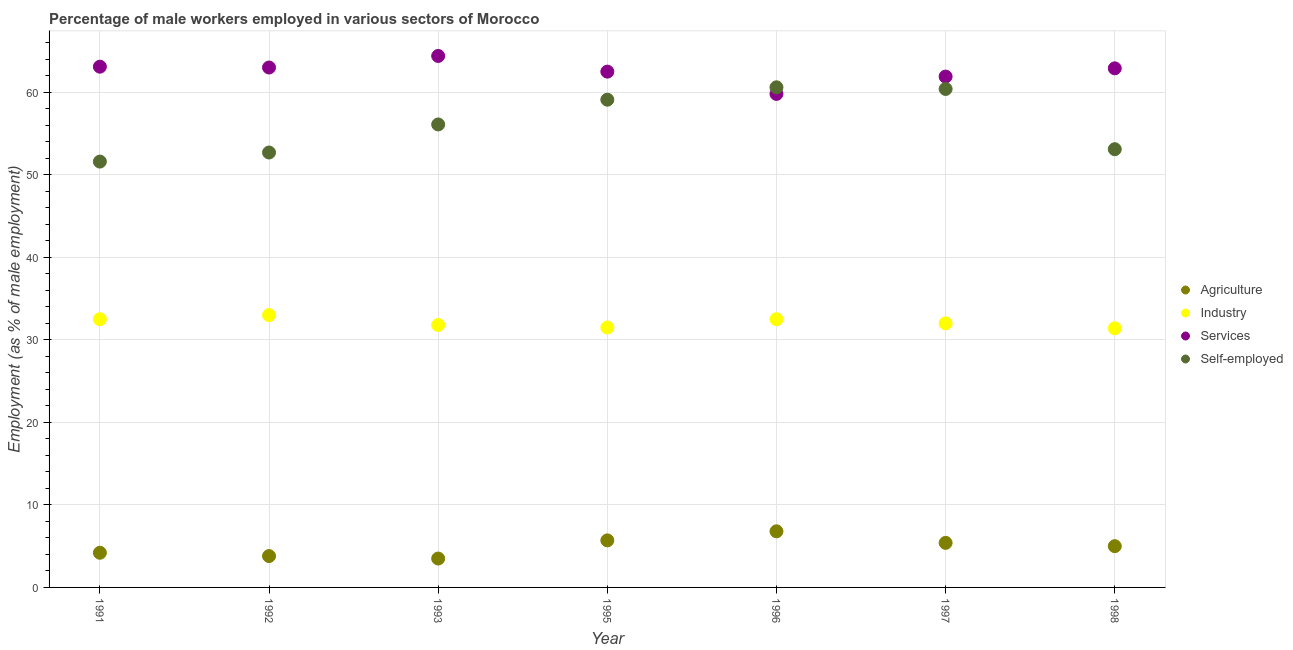How many different coloured dotlines are there?
Offer a very short reply. 4. Is the number of dotlines equal to the number of legend labels?
Your answer should be compact. Yes. What is the percentage of male workers in industry in 1993?
Offer a very short reply. 31.8. Across all years, what is the minimum percentage of male workers in services?
Give a very brief answer. 59.8. In which year was the percentage of male workers in services maximum?
Make the answer very short. 1993. In which year was the percentage of self employed male workers minimum?
Provide a short and direct response. 1991. What is the total percentage of male workers in services in the graph?
Make the answer very short. 437.6. What is the difference between the percentage of male workers in agriculture in 1992 and that in 1993?
Offer a very short reply. 0.3. What is the difference between the percentage of male workers in services in 1997 and the percentage of male workers in agriculture in 1992?
Make the answer very short. 58.1. What is the average percentage of male workers in agriculture per year?
Your answer should be very brief. 4.91. In the year 1993, what is the difference between the percentage of self employed male workers and percentage of male workers in services?
Provide a succinct answer. -8.3. In how many years, is the percentage of male workers in agriculture greater than 54 %?
Provide a succinct answer. 0. What is the ratio of the percentage of male workers in agriculture in 1992 to that in 1996?
Offer a terse response. 0.56. Is the percentage of male workers in industry in 1992 less than that in 1995?
Provide a succinct answer. No. What is the difference between the highest and the second highest percentage of male workers in services?
Provide a short and direct response. 1.3. What is the difference between the highest and the lowest percentage of male workers in services?
Make the answer very short. 4.6. Is it the case that in every year, the sum of the percentage of male workers in agriculture and percentage of male workers in industry is greater than the percentage of male workers in services?
Give a very brief answer. No. Does the percentage of male workers in industry monotonically increase over the years?
Provide a short and direct response. No. Are the values on the major ticks of Y-axis written in scientific E-notation?
Provide a short and direct response. No. Does the graph contain any zero values?
Your response must be concise. No. Does the graph contain grids?
Your answer should be compact. Yes. Where does the legend appear in the graph?
Offer a very short reply. Center right. How many legend labels are there?
Provide a succinct answer. 4. How are the legend labels stacked?
Your answer should be very brief. Vertical. What is the title of the graph?
Provide a short and direct response. Percentage of male workers employed in various sectors of Morocco. What is the label or title of the Y-axis?
Keep it short and to the point. Employment (as % of male employment). What is the Employment (as % of male employment) of Agriculture in 1991?
Make the answer very short. 4.2. What is the Employment (as % of male employment) of Industry in 1991?
Offer a terse response. 32.5. What is the Employment (as % of male employment) of Services in 1991?
Provide a short and direct response. 63.1. What is the Employment (as % of male employment) of Self-employed in 1991?
Offer a very short reply. 51.6. What is the Employment (as % of male employment) of Agriculture in 1992?
Keep it short and to the point. 3.8. What is the Employment (as % of male employment) of Industry in 1992?
Provide a short and direct response. 33. What is the Employment (as % of male employment) in Services in 1992?
Your answer should be compact. 63. What is the Employment (as % of male employment) in Self-employed in 1992?
Your answer should be compact. 52.7. What is the Employment (as % of male employment) of Industry in 1993?
Ensure brevity in your answer.  31.8. What is the Employment (as % of male employment) in Services in 1993?
Provide a short and direct response. 64.4. What is the Employment (as % of male employment) in Self-employed in 1993?
Provide a succinct answer. 56.1. What is the Employment (as % of male employment) in Agriculture in 1995?
Offer a terse response. 5.7. What is the Employment (as % of male employment) in Industry in 1995?
Your answer should be compact. 31.5. What is the Employment (as % of male employment) of Services in 1995?
Keep it short and to the point. 62.5. What is the Employment (as % of male employment) in Self-employed in 1995?
Your response must be concise. 59.1. What is the Employment (as % of male employment) in Agriculture in 1996?
Ensure brevity in your answer.  6.8. What is the Employment (as % of male employment) of Industry in 1996?
Your response must be concise. 32.5. What is the Employment (as % of male employment) of Services in 1996?
Keep it short and to the point. 59.8. What is the Employment (as % of male employment) in Self-employed in 1996?
Your answer should be compact. 60.6. What is the Employment (as % of male employment) in Agriculture in 1997?
Make the answer very short. 5.4. What is the Employment (as % of male employment) of Services in 1997?
Provide a succinct answer. 61.9. What is the Employment (as % of male employment) of Self-employed in 1997?
Provide a short and direct response. 60.4. What is the Employment (as % of male employment) in Agriculture in 1998?
Give a very brief answer. 5. What is the Employment (as % of male employment) of Industry in 1998?
Provide a succinct answer. 31.4. What is the Employment (as % of male employment) in Services in 1998?
Your answer should be very brief. 62.9. What is the Employment (as % of male employment) of Self-employed in 1998?
Provide a short and direct response. 53.1. Across all years, what is the maximum Employment (as % of male employment) in Agriculture?
Give a very brief answer. 6.8. Across all years, what is the maximum Employment (as % of male employment) of Services?
Offer a terse response. 64.4. Across all years, what is the maximum Employment (as % of male employment) of Self-employed?
Offer a very short reply. 60.6. Across all years, what is the minimum Employment (as % of male employment) of Industry?
Provide a short and direct response. 31.4. Across all years, what is the minimum Employment (as % of male employment) in Services?
Offer a terse response. 59.8. Across all years, what is the minimum Employment (as % of male employment) in Self-employed?
Ensure brevity in your answer.  51.6. What is the total Employment (as % of male employment) in Agriculture in the graph?
Keep it short and to the point. 34.4. What is the total Employment (as % of male employment) in Industry in the graph?
Give a very brief answer. 224.7. What is the total Employment (as % of male employment) of Services in the graph?
Provide a succinct answer. 437.6. What is the total Employment (as % of male employment) in Self-employed in the graph?
Your response must be concise. 393.6. What is the difference between the Employment (as % of male employment) in Industry in 1991 and that in 1992?
Your response must be concise. -0.5. What is the difference between the Employment (as % of male employment) in Services in 1991 and that in 1992?
Give a very brief answer. 0.1. What is the difference between the Employment (as % of male employment) of Agriculture in 1991 and that in 1993?
Your response must be concise. 0.7. What is the difference between the Employment (as % of male employment) of Industry in 1991 and that in 1993?
Provide a succinct answer. 0.7. What is the difference between the Employment (as % of male employment) of Self-employed in 1991 and that in 1993?
Your answer should be compact. -4.5. What is the difference between the Employment (as % of male employment) of Agriculture in 1991 and that in 1995?
Provide a short and direct response. -1.5. What is the difference between the Employment (as % of male employment) of Industry in 1991 and that in 1995?
Your answer should be compact. 1. What is the difference between the Employment (as % of male employment) of Services in 1991 and that in 1995?
Offer a terse response. 0.6. What is the difference between the Employment (as % of male employment) of Self-employed in 1991 and that in 1995?
Give a very brief answer. -7.5. What is the difference between the Employment (as % of male employment) of Services in 1991 and that in 1996?
Your answer should be very brief. 3.3. What is the difference between the Employment (as % of male employment) in Self-employed in 1991 and that in 1996?
Your answer should be compact. -9. What is the difference between the Employment (as % of male employment) of Agriculture in 1991 and that in 1997?
Provide a short and direct response. -1.2. What is the difference between the Employment (as % of male employment) of Services in 1991 and that in 1997?
Keep it short and to the point. 1.2. What is the difference between the Employment (as % of male employment) in Industry in 1991 and that in 1998?
Offer a very short reply. 1.1. What is the difference between the Employment (as % of male employment) in Services in 1991 and that in 1998?
Ensure brevity in your answer.  0.2. What is the difference between the Employment (as % of male employment) in Agriculture in 1992 and that in 1993?
Your response must be concise. 0.3. What is the difference between the Employment (as % of male employment) in Industry in 1992 and that in 1993?
Keep it short and to the point. 1.2. What is the difference between the Employment (as % of male employment) in Self-employed in 1992 and that in 1993?
Provide a short and direct response. -3.4. What is the difference between the Employment (as % of male employment) of Industry in 1992 and that in 1995?
Give a very brief answer. 1.5. What is the difference between the Employment (as % of male employment) in Agriculture in 1992 and that in 1996?
Make the answer very short. -3. What is the difference between the Employment (as % of male employment) in Industry in 1992 and that in 1996?
Offer a very short reply. 0.5. What is the difference between the Employment (as % of male employment) of Services in 1992 and that in 1996?
Keep it short and to the point. 3.2. What is the difference between the Employment (as % of male employment) of Self-employed in 1992 and that in 1996?
Offer a terse response. -7.9. What is the difference between the Employment (as % of male employment) in Industry in 1992 and that in 1997?
Offer a terse response. 1. What is the difference between the Employment (as % of male employment) of Self-employed in 1992 and that in 1997?
Give a very brief answer. -7.7. What is the difference between the Employment (as % of male employment) of Agriculture in 1992 and that in 1998?
Provide a short and direct response. -1.2. What is the difference between the Employment (as % of male employment) in Industry in 1992 and that in 1998?
Your response must be concise. 1.6. What is the difference between the Employment (as % of male employment) of Services in 1992 and that in 1998?
Your response must be concise. 0.1. What is the difference between the Employment (as % of male employment) of Services in 1993 and that in 1995?
Ensure brevity in your answer.  1.9. What is the difference between the Employment (as % of male employment) in Self-employed in 1993 and that in 1995?
Offer a terse response. -3. What is the difference between the Employment (as % of male employment) in Agriculture in 1993 and that in 1996?
Provide a short and direct response. -3.3. What is the difference between the Employment (as % of male employment) in Industry in 1993 and that in 1996?
Provide a succinct answer. -0.7. What is the difference between the Employment (as % of male employment) of Agriculture in 1993 and that in 1997?
Offer a very short reply. -1.9. What is the difference between the Employment (as % of male employment) in Industry in 1993 and that in 1997?
Your answer should be very brief. -0.2. What is the difference between the Employment (as % of male employment) in Self-employed in 1993 and that in 1997?
Your response must be concise. -4.3. What is the difference between the Employment (as % of male employment) of Agriculture in 1993 and that in 1998?
Keep it short and to the point. -1.5. What is the difference between the Employment (as % of male employment) of Industry in 1993 and that in 1998?
Make the answer very short. 0.4. What is the difference between the Employment (as % of male employment) in Services in 1993 and that in 1998?
Give a very brief answer. 1.5. What is the difference between the Employment (as % of male employment) in Agriculture in 1995 and that in 1996?
Offer a terse response. -1.1. What is the difference between the Employment (as % of male employment) in Industry in 1995 and that in 1996?
Make the answer very short. -1. What is the difference between the Employment (as % of male employment) in Agriculture in 1995 and that in 1998?
Your response must be concise. 0.7. What is the difference between the Employment (as % of male employment) in Agriculture in 1996 and that in 1997?
Provide a short and direct response. 1.4. What is the difference between the Employment (as % of male employment) of Industry in 1996 and that in 1997?
Offer a very short reply. 0.5. What is the difference between the Employment (as % of male employment) in Services in 1996 and that in 1997?
Offer a very short reply. -2.1. What is the difference between the Employment (as % of male employment) of Agriculture in 1997 and that in 1998?
Offer a very short reply. 0.4. What is the difference between the Employment (as % of male employment) of Agriculture in 1991 and the Employment (as % of male employment) of Industry in 1992?
Provide a succinct answer. -28.8. What is the difference between the Employment (as % of male employment) of Agriculture in 1991 and the Employment (as % of male employment) of Services in 1992?
Keep it short and to the point. -58.8. What is the difference between the Employment (as % of male employment) in Agriculture in 1991 and the Employment (as % of male employment) in Self-employed in 1992?
Keep it short and to the point. -48.5. What is the difference between the Employment (as % of male employment) in Industry in 1991 and the Employment (as % of male employment) in Services in 1992?
Keep it short and to the point. -30.5. What is the difference between the Employment (as % of male employment) in Industry in 1991 and the Employment (as % of male employment) in Self-employed in 1992?
Ensure brevity in your answer.  -20.2. What is the difference between the Employment (as % of male employment) in Services in 1991 and the Employment (as % of male employment) in Self-employed in 1992?
Offer a terse response. 10.4. What is the difference between the Employment (as % of male employment) of Agriculture in 1991 and the Employment (as % of male employment) of Industry in 1993?
Give a very brief answer. -27.6. What is the difference between the Employment (as % of male employment) of Agriculture in 1991 and the Employment (as % of male employment) of Services in 1993?
Your answer should be very brief. -60.2. What is the difference between the Employment (as % of male employment) of Agriculture in 1991 and the Employment (as % of male employment) of Self-employed in 1993?
Give a very brief answer. -51.9. What is the difference between the Employment (as % of male employment) in Industry in 1991 and the Employment (as % of male employment) in Services in 1993?
Offer a very short reply. -31.9. What is the difference between the Employment (as % of male employment) of Industry in 1991 and the Employment (as % of male employment) of Self-employed in 1993?
Your response must be concise. -23.6. What is the difference between the Employment (as % of male employment) in Agriculture in 1991 and the Employment (as % of male employment) in Industry in 1995?
Your answer should be very brief. -27.3. What is the difference between the Employment (as % of male employment) of Agriculture in 1991 and the Employment (as % of male employment) of Services in 1995?
Ensure brevity in your answer.  -58.3. What is the difference between the Employment (as % of male employment) of Agriculture in 1991 and the Employment (as % of male employment) of Self-employed in 1995?
Provide a short and direct response. -54.9. What is the difference between the Employment (as % of male employment) of Industry in 1991 and the Employment (as % of male employment) of Services in 1995?
Your answer should be very brief. -30. What is the difference between the Employment (as % of male employment) in Industry in 1991 and the Employment (as % of male employment) in Self-employed in 1995?
Make the answer very short. -26.6. What is the difference between the Employment (as % of male employment) of Services in 1991 and the Employment (as % of male employment) of Self-employed in 1995?
Your response must be concise. 4. What is the difference between the Employment (as % of male employment) in Agriculture in 1991 and the Employment (as % of male employment) in Industry in 1996?
Make the answer very short. -28.3. What is the difference between the Employment (as % of male employment) in Agriculture in 1991 and the Employment (as % of male employment) in Services in 1996?
Offer a very short reply. -55.6. What is the difference between the Employment (as % of male employment) in Agriculture in 1991 and the Employment (as % of male employment) in Self-employed in 1996?
Your response must be concise. -56.4. What is the difference between the Employment (as % of male employment) of Industry in 1991 and the Employment (as % of male employment) of Services in 1996?
Your answer should be very brief. -27.3. What is the difference between the Employment (as % of male employment) in Industry in 1991 and the Employment (as % of male employment) in Self-employed in 1996?
Provide a short and direct response. -28.1. What is the difference between the Employment (as % of male employment) in Agriculture in 1991 and the Employment (as % of male employment) in Industry in 1997?
Provide a short and direct response. -27.8. What is the difference between the Employment (as % of male employment) of Agriculture in 1991 and the Employment (as % of male employment) of Services in 1997?
Your answer should be very brief. -57.7. What is the difference between the Employment (as % of male employment) in Agriculture in 1991 and the Employment (as % of male employment) in Self-employed in 1997?
Keep it short and to the point. -56.2. What is the difference between the Employment (as % of male employment) in Industry in 1991 and the Employment (as % of male employment) in Services in 1997?
Offer a terse response. -29.4. What is the difference between the Employment (as % of male employment) of Industry in 1991 and the Employment (as % of male employment) of Self-employed in 1997?
Your answer should be compact. -27.9. What is the difference between the Employment (as % of male employment) of Agriculture in 1991 and the Employment (as % of male employment) of Industry in 1998?
Offer a very short reply. -27.2. What is the difference between the Employment (as % of male employment) of Agriculture in 1991 and the Employment (as % of male employment) of Services in 1998?
Give a very brief answer. -58.7. What is the difference between the Employment (as % of male employment) of Agriculture in 1991 and the Employment (as % of male employment) of Self-employed in 1998?
Your answer should be compact. -48.9. What is the difference between the Employment (as % of male employment) of Industry in 1991 and the Employment (as % of male employment) of Services in 1998?
Your answer should be very brief. -30.4. What is the difference between the Employment (as % of male employment) in Industry in 1991 and the Employment (as % of male employment) in Self-employed in 1998?
Make the answer very short. -20.6. What is the difference between the Employment (as % of male employment) in Agriculture in 1992 and the Employment (as % of male employment) in Services in 1993?
Provide a short and direct response. -60.6. What is the difference between the Employment (as % of male employment) of Agriculture in 1992 and the Employment (as % of male employment) of Self-employed in 1993?
Provide a succinct answer. -52.3. What is the difference between the Employment (as % of male employment) in Industry in 1992 and the Employment (as % of male employment) in Services in 1993?
Your response must be concise. -31.4. What is the difference between the Employment (as % of male employment) of Industry in 1992 and the Employment (as % of male employment) of Self-employed in 1993?
Provide a succinct answer. -23.1. What is the difference between the Employment (as % of male employment) in Agriculture in 1992 and the Employment (as % of male employment) in Industry in 1995?
Offer a terse response. -27.7. What is the difference between the Employment (as % of male employment) of Agriculture in 1992 and the Employment (as % of male employment) of Services in 1995?
Keep it short and to the point. -58.7. What is the difference between the Employment (as % of male employment) of Agriculture in 1992 and the Employment (as % of male employment) of Self-employed in 1995?
Your response must be concise. -55.3. What is the difference between the Employment (as % of male employment) of Industry in 1992 and the Employment (as % of male employment) of Services in 1995?
Give a very brief answer. -29.5. What is the difference between the Employment (as % of male employment) of Industry in 1992 and the Employment (as % of male employment) of Self-employed in 1995?
Provide a succinct answer. -26.1. What is the difference between the Employment (as % of male employment) of Services in 1992 and the Employment (as % of male employment) of Self-employed in 1995?
Your answer should be compact. 3.9. What is the difference between the Employment (as % of male employment) of Agriculture in 1992 and the Employment (as % of male employment) of Industry in 1996?
Offer a terse response. -28.7. What is the difference between the Employment (as % of male employment) of Agriculture in 1992 and the Employment (as % of male employment) of Services in 1996?
Your answer should be compact. -56. What is the difference between the Employment (as % of male employment) of Agriculture in 1992 and the Employment (as % of male employment) of Self-employed in 1996?
Your answer should be very brief. -56.8. What is the difference between the Employment (as % of male employment) of Industry in 1992 and the Employment (as % of male employment) of Services in 1996?
Provide a short and direct response. -26.8. What is the difference between the Employment (as % of male employment) in Industry in 1992 and the Employment (as % of male employment) in Self-employed in 1996?
Provide a short and direct response. -27.6. What is the difference between the Employment (as % of male employment) in Services in 1992 and the Employment (as % of male employment) in Self-employed in 1996?
Give a very brief answer. 2.4. What is the difference between the Employment (as % of male employment) of Agriculture in 1992 and the Employment (as % of male employment) of Industry in 1997?
Provide a short and direct response. -28.2. What is the difference between the Employment (as % of male employment) of Agriculture in 1992 and the Employment (as % of male employment) of Services in 1997?
Make the answer very short. -58.1. What is the difference between the Employment (as % of male employment) of Agriculture in 1992 and the Employment (as % of male employment) of Self-employed in 1997?
Make the answer very short. -56.6. What is the difference between the Employment (as % of male employment) of Industry in 1992 and the Employment (as % of male employment) of Services in 1997?
Ensure brevity in your answer.  -28.9. What is the difference between the Employment (as % of male employment) of Industry in 1992 and the Employment (as % of male employment) of Self-employed in 1997?
Provide a short and direct response. -27.4. What is the difference between the Employment (as % of male employment) in Services in 1992 and the Employment (as % of male employment) in Self-employed in 1997?
Your answer should be compact. 2.6. What is the difference between the Employment (as % of male employment) of Agriculture in 1992 and the Employment (as % of male employment) of Industry in 1998?
Your answer should be compact. -27.6. What is the difference between the Employment (as % of male employment) in Agriculture in 1992 and the Employment (as % of male employment) in Services in 1998?
Make the answer very short. -59.1. What is the difference between the Employment (as % of male employment) in Agriculture in 1992 and the Employment (as % of male employment) in Self-employed in 1998?
Your answer should be very brief. -49.3. What is the difference between the Employment (as % of male employment) in Industry in 1992 and the Employment (as % of male employment) in Services in 1998?
Keep it short and to the point. -29.9. What is the difference between the Employment (as % of male employment) of Industry in 1992 and the Employment (as % of male employment) of Self-employed in 1998?
Make the answer very short. -20.1. What is the difference between the Employment (as % of male employment) in Agriculture in 1993 and the Employment (as % of male employment) in Services in 1995?
Your answer should be very brief. -59. What is the difference between the Employment (as % of male employment) of Agriculture in 1993 and the Employment (as % of male employment) of Self-employed in 1995?
Your response must be concise. -55.6. What is the difference between the Employment (as % of male employment) of Industry in 1993 and the Employment (as % of male employment) of Services in 1995?
Make the answer very short. -30.7. What is the difference between the Employment (as % of male employment) of Industry in 1993 and the Employment (as % of male employment) of Self-employed in 1995?
Provide a succinct answer. -27.3. What is the difference between the Employment (as % of male employment) of Agriculture in 1993 and the Employment (as % of male employment) of Industry in 1996?
Provide a short and direct response. -29. What is the difference between the Employment (as % of male employment) of Agriculture in 1993 and the Employment (as % of male employment) of Services in 1996?
Make the answer very short. -56.3. What is the difference between the Employment (as % of male employment) of Agriculture in 1993 and the Employment (as % of male employment) of Self-employed in 1996?
Your answer should be very brief. -57.1. What is the difference between the Employment (as % of male employment) in Industry in 1993 and the Employment (as % of male employment) in Services in 1996?
Your answer should be very brief. -28. What is the difference between the Employment (as % of male employment) in Industry in 1993 and the Employment (as % of male employment) in Self-employed in 1996?
Provide a succinct answer. -28.8. What is the difference between the Employment (as % of male employment) in Services in 1993 and the Employment (as % of male employment) in Self-employed in 1996?
Provide a short and direct response. 3.8. What is the difference between the Employment (as % of male employment) in Agriculture in 1993 and the Employment (as % of male employment) in Industry in 1997?
Ensure brevity in your answer.  -28.5. What is the difference between the Employment (as % of male employment) of Agriculture in 1993 and the Employment (as % of male employment) of Services in 1997?
Your response must be concise. -58.4. What is the difference between the Employment (as % of male employment) in Agriculture in 1993 and the Employment (as % of male employment) in Self-employed in 1997?
Your answer should be compact. -56.9. What is the difference between the Employment (as % of male employment) of Industry in 1993 and the Employment (as % of male employment) of Services in 1997?
Make the answer very short. -30.1. What is the difference between the Employment (as % of male employment) in Industry in 1993 and the Employment (as % of male employment) in Self-employed in 1997?
Provide a short and direct response. -28.6. What is the difference between the Employment (as % of male employment) in Agriculture in 1993 and the Employment (as % of male employment) in Industry in 1998?
Keep it short and to the point. -27.9. What is the difference between the Employment (as % of male employment) in Agriculture in 1993 and the Employment (as % of male employment) in Services in 1998?
Offer a very short reply. -59.4. What is the difference between the Employment (as % of male employment) of Agriculture in 1993 and the Employment (as % of male employment) of Self-employed in 1998?
Give a very brief answer. -49.6. What is the difference between the Employment (as % of male employment) in Industry in 1993 and the Employment (as % of male employment) in Services in 1998?
Your answer should be compact. -31.1. What is the difference between the Employment (as % of male employment) of Industry in 1993 and the Employment (as % of male employment) of Self-employed in 1998?
Give a very brief answer. -21.3. What is the difference between the Employment (as % of male employment) of Agriculture in 1995 and the Employment (as % of male employment) of Industry in 1996?
Make the answer very short. -26.8. What is the difference between the Employment (as % of male employment) in Agriculture in 1995 and the Employment (as % of male employment) in Services in 1996?
Keep it short and to the point. -54.1. What is the difference between the Employment (as % of male employment) of Agriculture in 1995 and the Employment (as % of male employment) of Self-employed in 1996?
Provide a succinct answer. -54.9. What is the difference between the Employment (as % of male employment) of Industry in 1995 and the Employment (as % of male employment) of Services in 1996?
Give a very brief answer. -28.3. What is the difference between the Employment (as % of male employment) of Industry in 1995 and the Employment (as % of male employment) of Self-employed in 1996?
Offer a terse response. -29.1. What is the difference between the Employment (as % of male employment) in Agriculture in 1995 and the Employment (as % of male employment) in Industry in 1997?
Provide a short and direct response. -26.3. What is the difference between the Employment (as % of male employment) in Agriculture in 1995 and the Employment (as % of male employment) in Services in 1997?
Your response must be concise. -56.2. What is the difference between the Employment (as % of male employment) in Agriculture in 1995 and the Employment (as % of male employment) in Self-employed in 1997?
Your answer should be compact. -54.7. What is the difference between the Employment (as % of male employment) of Industry in 1995 and the Employment (as % of male employment) of Services in 1997?
Your answer should be compact. -30.4. What is the difference between the Employment (as % of male employment) in Industry in 1995 and the Employment (as % of male employment) in Self-employed in 1997?
Keep it short and to the point. -28.9. What is the difference between the Employment (as % of male employment) of Agriculture in 1995 and the Employment (as % of male employment) of Industry in 1998?
Your response must be concise. -25.7. What is the difference between the Employment (as % of male employment) of Agriculture in 1995 and the Employment (as % of male employment) of Services in 1998?
Provide a succinct answer. -57.2. What is the difference between the Employment (as % of male employment) of Agriculture in 1995 and the Employment (as % of male employment) of Self-employed in 1998?
Your response must be concise. -47.4. What is the difference between the Employment (as % of male employment) in Industry in 1995 and the Employment (as % of male employment) in Services in 1998?
Provide a succinct answer. -31.4. What is the difference between the Employment (as % of male employment) in Industry in 1995 and the Employment (as % of male employment) in Self-employed in 1998?
Make the answer very short. -21.6. What is the difference between the Employment (as % of male employment) in Agriculture in 1996 and the Employment (as % of male employment) in Industry in 1997?
Your answer should be very brief. -25.2. What is the difference between the Employment (as % of male employment) in Agriculture in 1996 and the Employment (as % of male employment) in Services in 1997?
Make the answer very short. -55.1. What is the difference between the Employment (as % of male employment) of Agriculture in 1996 and the Employment (as % of male employment) of Self-employed in 1997?
Keep it short and to the point. -53.6. What is the difference between the Employment (as % of male employment) of Industry in 1996 and the Employment (as % of male employment) of Services in 1997?
Offer a very short reply. -29.4. What is the difference between the Employment (as % of male employment) in Industry in 1996 and the Employment (as % of male employment) in Self-employed in 1997?
Keep it short and to the point. -27.9. What is the difference between the Employment (as % of male employment) in Services in 1996 and the Employment (as % of male employment) in Self-employed in 1997?
Your response must be concise. -0.6. What is the difference between the Employment (as % of male employment) in Agriculture in 1996 and the Employment (as % of male employment) in Industry in 1998?
Provide a short and direct response. -24.6. What is the difference between the Employment (as % of male employment) of Agriculture in 1996 and the Employment (as % of male employment) of Services in 1998?
Give a very brief answer. -56.1. What is the difference between the Employment (as % of male employment) in Agriculture in 1996 and the Employment (as % of male employment) in Self-employed in 1998?
Your response must be concise. -46.3. What is the difference between the Employment (as % of male employment) in Industry in 1996 and the Employment (as % of male employment) in Services in 1998?
Provide a short and direct response. -30.4. What is the difference between the Employment (as % of male employment) of Industry in 1996 and the Employment (as % of male employment) of Self-employed in 1998?
Make the answer very short. -20.6. What is the difference between the Employment (as % of male employment) of Services in 1996 and the Employment (as % of male employment) of Self-employed in 1998?
Offer a very short reply. 6.7. What is the difference between the Employment (as % of male employment) in Agriculture in 1997 and the Employment (as % of male employment) in Industry in 1998?
Provide a short and direct response. -26. What is the difference between the Employment (as % of male employment) of Agriculture in 1997 and the Employment (as % of male employment) of Services in 1998?
Offer a terse response. -57.5. What is the difference between the Employment (as % of male employment) of Agriculture in 1997 and the Employment (as % of male employment) of Self-employed in 1998?
Your response must be concise. -47.7. What is the difference between the Employment (as % of male employment) in Industry in 1997 and the Employment (as % of male employment) in Services in 1998?
Ensure brevity in your answer.  -30.9. What is the difference between the Employment (as % of male employment) in Industry in 1997 and the Employment (as % of male employment) in Self-employed in 1998?
Your answer should be compact. -21.1. What is the difference between the Employment (as % of male employment) in Services in 1997 and the Employment (as % of male employment) in Self-employed in 1998?
Provide a short and direct response. 8.8. What is the average Employment (as % of male employment) of Agriculture per year?
Give a very brief answer. 4.91. What is the average Employment (as % of male employment) of Industry per year?
Keep it short and to the point. 32.1. What is the average Employment (as % of male employment) in Services per year?
Give a very brief answer. 62.51. What is the average Employment (as % of male employment) of Self-employed per year?
Offer a very short reply. 56.23. In the year 1991, what is the difference between the Employment (as % of male employment) in Agriculture and Employment (as % of male employment) in Industry?
Provide a succinct answer. -28.3. In the year 1991, what is the difference between the Employment (as % of male employment) in Agriculture and Employment (as % of male employment) in Services?
Give a very brief answer. -58.9. In the year 1991, what is the difference between the Employment (as % of male employment) in Agriculture and Employment (as % of male employment) in Self-employed?
Provide a succinct answer. -47.4. In the year 1991, what is the difference between the Employment (as % of male employment) in Industry and Employment (as % of male employment) in Services?
Your answer should be compact. -30.6. In the year 1991, what is the difference between the Employment (as % of male employment) of Industry and Employment (as % of male employment) of Self-employed?
Your answer should be compact. -19.1. In the year 1991, what is the difference between the Employment (as % of male employment) of Services and Employment (as % of male employment) of Self-employed?
Offer a very short reply. 11.5. In the year 1992, what is the difference between the Employment (as % of male employment) of Agriculture and Employment (as % of male employment) of Industry?
Provide a short and direct response. -29.2. In the year 1992, what is the difference between the Employment (as % of male employment) of Agriculture and Employment (as % of male employment) of Services?
Make the answer very short. -59.2. In the year 1992, what is the difference between the Employment (as % of male employment) in Agriculture and Employment (as % of male employment) in Self-employed?
Provide a short and direct response. -48.9. In the year 1992, what is the difference between the Employment (as % of male employment) of Industry and Employment (as % of male employment) of Services?
Offer a terse response. -30. In the year 1992, what is the difference between the Employment (as % of male employment) in Industry and Employment (as % of male employment) in Self-employed?
Your answer should be very brief. -19.7. In the year 1992, what is the difference between the Employment (as % of male employment) in Services and Employment (as % of male employment) in Self-employed?
Ensure brevity in your answer.  10.3. In the year 1993, what is the difference between the Employment (as % of male employment) of Agriculture and Employment (as % of male employment) of Industry?
Your response must be concise. -28.3. In the year 1993, what is the difference between the Employment (as % of male employment) of Agriculture and Employment (as % of male employment) of Services?
Offer a terse response. -60.9. In the year 1993, what is the difference between the Employment (as % of male employment) of Agriculture and Employment (as % of male employment) of Self-employed?
Make the answer very short. -52.6. In the year 1993, what is the difference between the Employment (as % of male employment) in Industry and Employment (as % of male employment) in Services?
Your response must be concise. -32.6. In the year 1993, what is the difference between the Employment (as % of male employment) of Industry and Employment (as % of male employment) of Self-employed?
Ensure brevity in your answer.  -24.3. In the year 1993, what is the difference between the Employment (as % of male employment) in Services and Employment (as % of male employment) in Self-employed?
Provide a succinct answer. 8.3. In the year 1995, what is the difference between the Employment (as % of male employment) in Agriculture and Employment (as % of male employment) in Industry?
Offer a very short reply. -25.8. In the year 1995, what is the difference between the Employment (as % of male employment) in Agriculture and Employment (as % of male employment) in Services?
Make the answer very short. -56.8. In the year 1995, what is the difference between the Employment (as % of male employment) of Agriculture and Employment (as % of male employment) of Self-employed?
Make the answer very short. -53.4. In the year 1995, what is the difference between the Employment (as % of male employment) of Industry and Employment (as % of male employment) of Services?
Your answer should be compact. -31. In the year 1995, what is the difference between the Employment (as % of male employment) of Industry and Employment (as % of male employment) of Self-employed?
Make the answer very short. -27.6. In the year 1996, what is the difference between the Employment (as % of male employment) of Agriculture and Employment (as % of male employment) of Industry?
Give a very brief answer. -25.7. In the year 1996, what is the difference between the Employment (as % of male employment) of Agriculture and Employment (as % of male employment) of Services?
Offer a very short reply. -53. In the year 1996, what is the difference between the Employment (as % of male employment) in Agriculture and Employment (as % of male employment) in Self-employed?
Offer a very short reply. -53.8. In the year 1996, what is the difference between the Employment (as % of male employment) in Industry and Employment (as % of male employment) in Services?
Offer a terse response. -27.3. In the year 1996, what is the difference between the Employment (as % of male employment) of Industry and Employment (as % of male employment) of Self-employed?
Offer a very short reply. -28.1. In the year 1996, what is the difference between the Employment (as % of male employment) of Services and Employment (as % of male employment) of Self-employed?
Give a very brief answer. -0.8. In the year 1997, what is the difference between the Employment (as % of male employment) of Agriculture and Employment (as % of male employment) of Industry?
Your answer should be compact. -26.6. In the year 1997, what is the difference between the Employment (as % of male employment) in Agriculture and Employment (as % of male employment) in Services?
Give a very brief answer. -56.5. In the year 1997, what is the difference between the Employment (as % of male employment) in Agriculture and Employment (as % of male employment) in Self-employed?
Provide a short and direct response. -55. In the year 1997, what is the difference between the Employment (as % of male employment) of Industry and Employment (as % of male employment) of Services?
Provide a succinct answer. -29.9. In the year 1997, what is the difference between the Employment (as % of male employment) of Industry and Employment (as % of male employment) of Self-employed?
Keep it short and to the point. -28.4. In the year 1997, what is the difference between the Employment (as % of male employment) of Services and Employment (as % of male employment) of Self-employed?
Give a very brief answer. 1.5. In the year 1998, what is the difference between the Employment (as % of male employment) in Agriculture and Employment (as % of male employment) in Industry?
Your answer should be very brief. -26.4. In the year 1998, what is the difference between the Employment (as % of male employment) of Agriculture and Employment (as % of male employment) of Services?
Offer a terse response. -57.9. In the year 1998, what is the difference between the Employment (as % of male employment) of Agriculture and Employment (as % of male employment) of Self-employed?
Your answer should be very brief. -48.1. In the year 1998, what is the difference between the Employment (as % of male employment) in Industry and Employment (as % of male employment) in Services?
Your answer should be very brief. -31.5. In the year 1998, what is the difference between the Employment (as % of male employment) in Industry and Employment (as % of male employment) in Self-employed?
Make the answer very short. -21.7. In the year 1998, what is the difference between the Employment (as % of male employment) in Services and Employment (as % of male employment) in Self-employed?
Give a very brief answer. 9.8. What is the ratio of the Employment (as % of male employment) of Agriculture in 1991 to that in 1992?
Offer a very short reply. 1.11. What is the ratio of the Employment (as % of male employment) in Industry in 1991 to that in 1992?
Keep it short and to the point. 0.98. What is the ratio of the Employment (as % of male employment) of Services in 1991 to that in 1992?
Make the answer very short. 1. What is the ratio of the Employment (as % of male employment) of Self-employed in 1991 to that in 1992?
Your answer should be very brief. 0.98. What is the ratio of the Employment (as % of male employment) of Agriculture in 1991 to that in 1993?
Offer a very short reply. 1.2. What is the ratio of the Employment (as % of male employment) in Services in 1991 to that in 1993?
Your answer should be very brief. 0.98. What is the ratio of the Employment (as % of male employment) in Self-employed in 1991 to that in 1993?
Provide a short and direct response. 0.92. What is the ratio of the Employment (as % of male employment) in Agriculture in 1991 to that in 1995?
Ensure brevity in your answer.  0.74. What is the ratio of the Employment (as % of male employment) of Industry in 1991 to that in 1995?
Your answer should be very brief. 1.03. What is the ratio of the Employment (as % of male employment) of Services in 1991 to that in 1995?
Offer a very short reply. 1.01. What is the ratio of the Employment (as % of male employment) in Self-employed in 1991 to that in 1995?
Provide a succinct answer. 0.87. What is the ratio of the Employment (as % of male employment) in Agriculture in 1991 to that in 1996?
Ensure brevity in your answer.  0.62. What is the ratio of the Employment (as % of male employment) of Services in 1991 to that in 1996?
Offer a very short reply. 1.06. What is the ratio of the Employment (as % of male employment) of Self-employed in 1991 to that in 1996?
Provide a short and direct response. 0.85. What is the ratio of the Employment (as % of male employment) of Agriculture in 1991 to that in 1997?
Ensure brevity in your answer.  0.78. What is the ratio of the Employment (as % of male employment) in Industry in 1991 to that in 1997?
Make the answer very short. 1.02. What is the ratio of the Employment (as % of male employment) of Services in 1991 to that in 1997?
Make the answer very short. 1.02. What is the ratio of the Employment (as % of male employment) of Self-employed in 1991 to that in 1997?
Your answer should be compact. 0.85. What is the ratio of the Employment (as % of male employment) of Agriculture in 1991 to that in 1998?
Make the answer very short. 0.84. What is the ratio of the Employment (as % of male employment) in Industry in 1991 to that in 1998?
Provide a short and direct response. 1.03. What is the ratio of the Employment (as % of male employment) in Self-employed in 1991 to that in 1998?
Your answer should be compact. 0.97. What is the ratio of the Employment (as % of male employment) of Agriculture in 1992 to that in 1993?
Your answer should be compact. 1.09. What is the ratio of the Employment (as % of male employment) of Industry in 1992 to that in 1993?
Keep it short and to the point. 1.04. What is the ratio of the Employment (as % of male employment) of Services in 1992 to that in 1993?
Provide a succinct answer. 0.98. What is the ratio of the Employment (as % of male employment) in Self-employed in 1992 to that in 1993?
Your answer should be very brief. 0.94. What is the ratio of the Employment (as % of male employment) in Agriculture in 1992 to that in 1995?
Ensure brevity in your answer.  0.67. What is the ratio of the Employment (as % of male employment) of Industry in 1992 to that in 1995?
Make the answer very short. 1.05. What is the ratio of the Employment (as % of male employment) of Self-employed in 1992 to that in 1995?
Offer a terse response. 0.89. What is the ratio of the Employment (as % of male employment) of Agriculture in 1992 to that in 1996?
Offer a terse response. 0.56. What is the ratio of the Employment (as % of male employment) in Industry in 1992 to that in 1996?
Give a very brief answer. 1.02. What is the ratio of the Employment (as % of male employment) in Services in 1992 to that in 1996?
Provide a succinct answer. 1.05. What is the ratio of the Employment (as % of male employment) of Self-employed in 1992 to that in 1996?
Provide a succinct answer. 0.87. What is the ratio of the Employment (as % of male employment) in Agriculture in 1992 to that in 1997?
Give a very brief answer. 0.7. What is the ratio of the Employment (as % of male employment) in Industry in 1992 to that in 1997?
Give a very brief answer. 1.03. What is the ratio of the Employment (as % of male employment) in Services in 1992 to that in 1997?
Your response must be concise. 1.02. What is the ratio of the Employment (as % of male employment) of Self-employed in 1992 to that in 1997?
Make the answer very short. 0.87. What is the ratio of the Employment (as % of male employment) of Agriculture in 1992 to that in 1998?
Make the answer very short. 0.76. What is the ratio of the Employment (as % of male employment) in Industry in 1992 to that in 1998?
Your answer should be compact. 1.05. What is the ratio of the Employment (as % of male employment) in Services in 1992 to that in 1998?
Offer a very short reply. 1. What is the ratio of the Employment (as % of male employment) of Self-employed in 1992 to that in 1998?
Offer a terse response. 0.99. What is the ratio of the Employment (as % of male employment) in Agriculture in 1993 to that in 1995?
Keep it short and to the point. 0.61. What is the ratio of the Employment (as % of male employment) in Industry in 1993 to that in 1995?
Provide a succinct answer. 1.01. What is the ratio of the Employment (as % of male employment) in Services in 1993 to that in 1995?
Ensure brevity in your answer.  1.03. What is the ratio of the Employment (as % of male employment) in Self-employed in 1993 to that in 1995?
Make the answer very short. 0.95. What is the ratio of the Employment (as % of male employment) of Agriculture in 1993 to that in 1996?
Provide a succinct answer. 0.51. What is the ratio of the Employment (as % of male employment) of Industry in 1993 to that in 1996?
Keep it short and to the point. 0.98. What is the ratio of the Employment (as % of male employment) of Self-employed in 1993 to that in 1996?
Provide a succinct answer. 0.93. What is the ratio of the Employment (as % of male employment) in Agriculture in 1993 to that in 1997?
Provide a short and direct response. 0.65. What is the ratio of the Employment (as % of male employment) in Services in 1993 to that in 1997?
Your answer should be compact. 1.04. What is the ratio of the Employment (as % of male employment) in Self-employed in 1993 to that in 1997?
Offer a terse response. 0.93. What is the ratio of the Employment (as % of male employment) of Agriculture in 1993 to that in 1998?
Offer a terse response. 0.7. What is the ratio of the Employment (as % of male employment) of Industry in 1993 to that in 1998?
Give a very brief answer. 1.01. What is the ratio of the Employment (as % of male employment) of Services in 1993 to that in 1998?
Your answer should be very brief. 1.02. What is the ratio of the Employment (as % of male employment) of Self-employed in 1993 to that in 1998?
Make the answer very short. 1.06. What is the ratio of the Employment (as % of male employment) in Agriculture in 1995 to that in 1996?
Your answer should be very brief. 0.84. What is the ratio of the Employment (as % of male employment) in Industry in 1995 to that in 1996?
Keep it short and to the point. 0.97. What is the ratio of the Employment (as % of male employment) in Services in 1995 to that in 1996?
Make the answer very short. 1.05. What is the ratio of the Employment (as % of male employment) in Self-employed in 1995 to that in 1996?
Provide a short and direct response. 0.98. What is the ratio of the Employment (as % of male employment) of Agriculture in 1995 to that in 1997?
Provide a succinct answer. 1.06. What is the ratio of the Employment (as % of male employment) in Industry in 1995 to that in 1997?
Provide a succinct answer. 0.98. What is the ratio of the Employment (as % of male employment) of Services in 1995 to that in 1997?
Keep it short and to the point. 1.01. What is the ratio of the Employment (as % of male employment) of Self-employed in 1995 to that in 1997?
Ensure brevity in your answer.  0.98. What is the ratio of the Employment (as % of male employment) of Agriculture in 1995 to that in 1998?
Provide a succinct answer. 1.14. What is the ratio of the Employment (as % of male employment) in Self-employed in 1995 to that in 1998?
Keep it short and to the point. 1.11. What is the ratio of the Employment (as % of male employment) of Agriculture in 1996 to that in 1997?
Your response must be concise. 1.26. What is the ratio of the Employment (as % of male employment) in Industry in 1996 to that in 1997?
Offer a very short reply. 1.02. What is the ratio of the Employment (as % of male employment) in Services in 1996 to that in 1997?
Give a very brief answer. 0.97. What is the ratio of the Employment (as % of male employment) in Agriculture in 1996 to that in 1998?
Keep it short and to the point. 1.36. What is the ratio of the Employment (as % of male employment) in Industry in 1996 to that in 1998?
Provide a succinct answer. 1.03. What is the ratio of the Employment (as % of male employment) of Services in 1996 to that in 1998?
Provide a succinct answer. 0.95. What is the ratio of the Employment (as % of male employment) in Self-employed in 1996 to that in 1998?
Your answer should be compact. 1.14. What is the ratio of the Employment (as % of male employment) in Industry in 1997 to that in 1998?
Your answer should be very brief. 1.02. What is the ratio of the Employment (as % of male employment) of Services in 1997 to that in 1998?
Offer a terse response. 0.98. What is the ratio of the Employment (as % of male employment) in Self-employed in 1997 to that in 1998?
Provide a short and direct response. 1.14. What is the difference between the highest and the second highest Employment (as % of male employment) of Self-employed?
Ensure brevity in your answer.  0.2. 